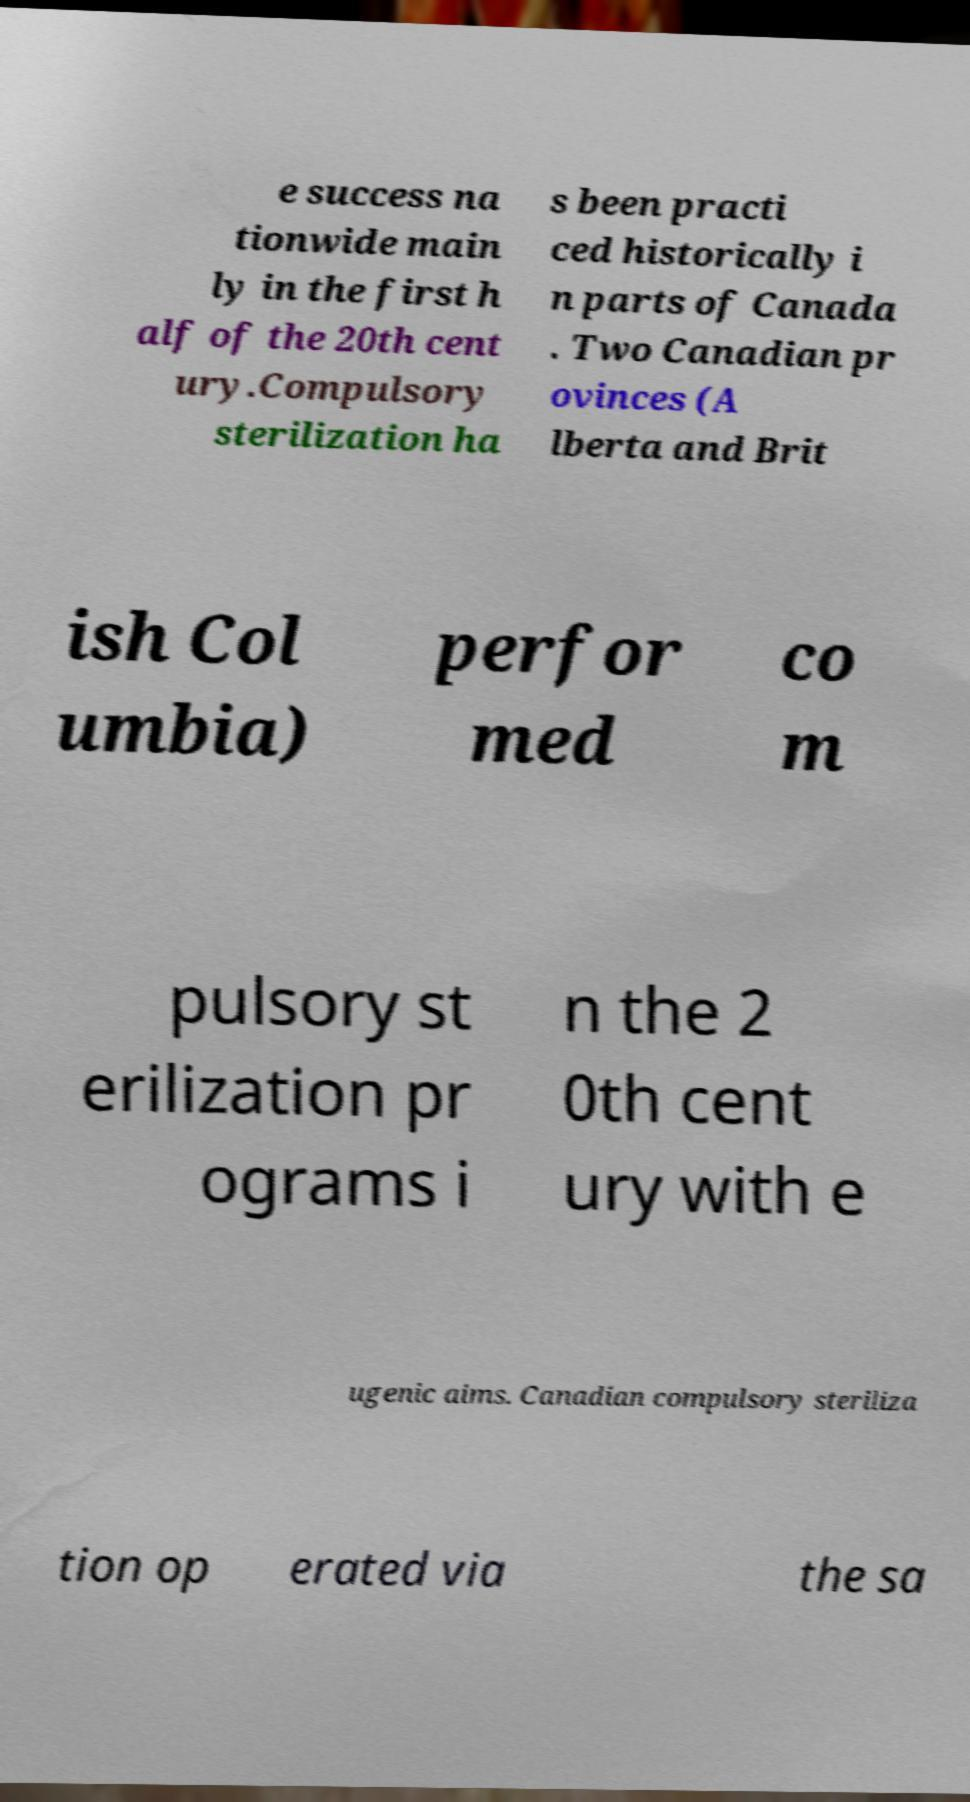Please read and relay the text visible in this image. What does it say? e success na tionwide main ly in the first h alf of the 20th cent ury.Compulsory sterilization ha s been practi ced historically i n parts of Canada . Two Canadian pr ovinces (A lberta and Brit ish Col umbia) perfor med co m pulsory st erilization pr ograms i n the 2 0th cent ury with e ugenic aims. Canadian compulsory steriliza tion op erated via the sa 